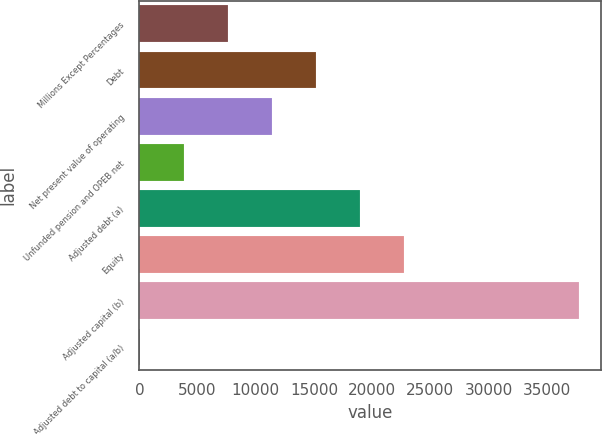Convert chart. <chart><loc_0><loc_0><loc_500><loc_500><bar_chart><fcel>Millions Except Percentages<fcel>Debt<fcel>Net present value of operating<fcel>Unfunded pension and OPEB net<fcel>Adjusted debt (a)<fcel>Equity<fcel>Adjusted capital (b)<fcel>Adjusted debt to capital (a/b)<nl><fcel>7599.84<fcel>15152.4<fcel>11376.1<fcel>3823.57<fcel>18928.7<fcel>22704.9<fcel>37810<fcel>47.3<nl></chart> 